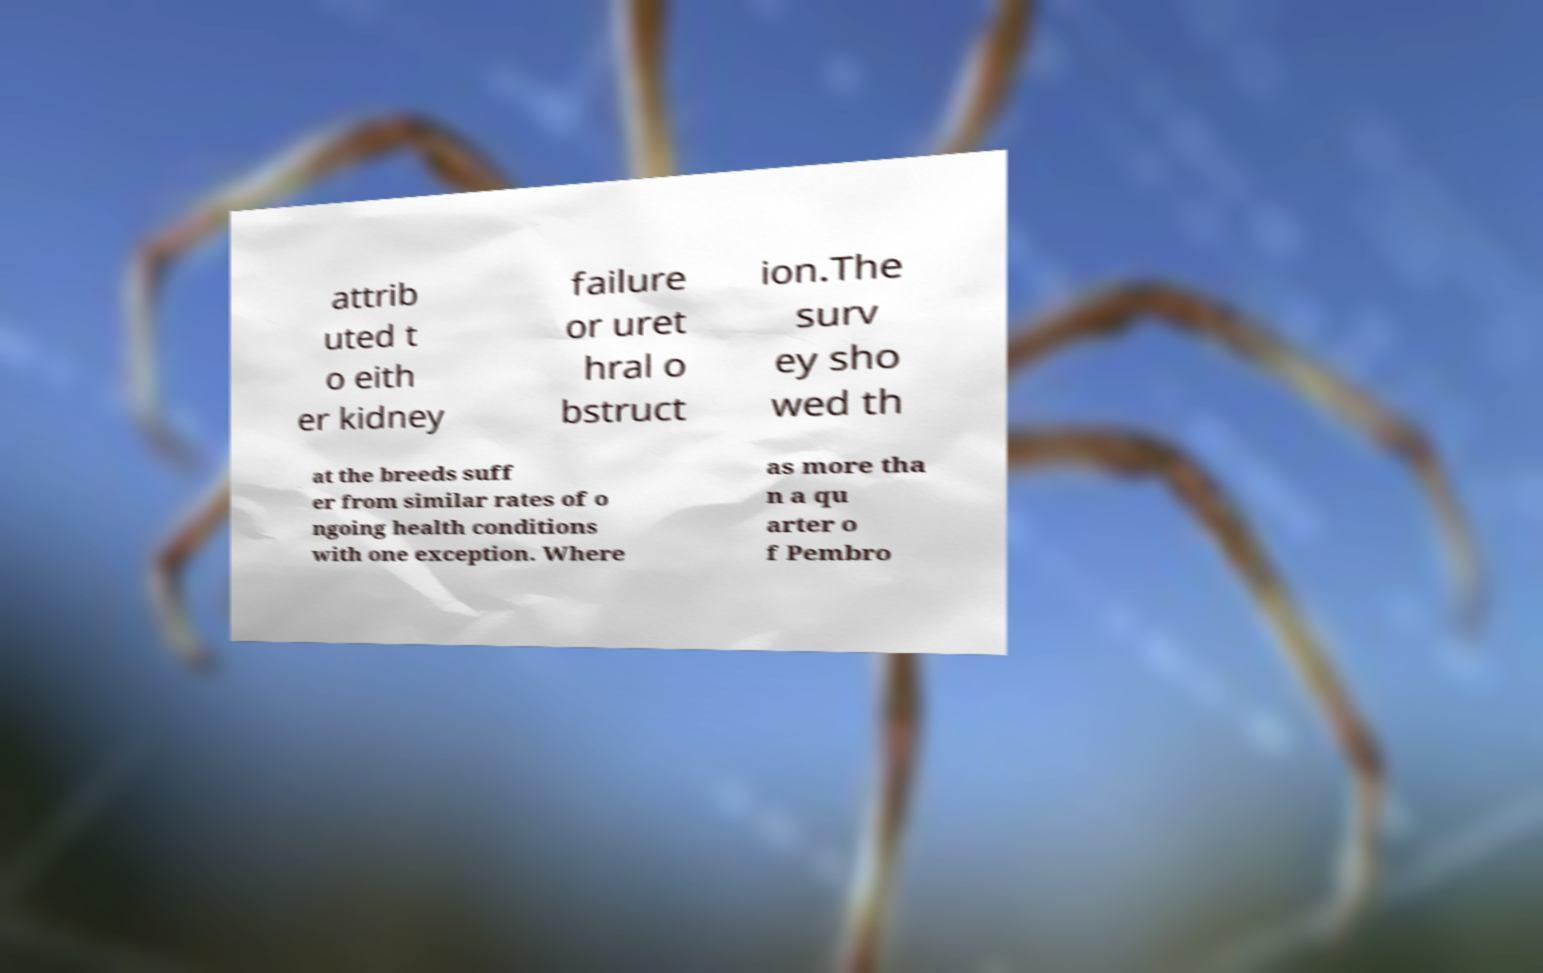Could you assist in decoding the text presented in this image and type it out clearly? attrib uted t o eith er kidney failure or uret hral o bstruct ion.The surv ey sho wed th at the breeds suff er from similar rates of o ngoing health conditions with one exception. Where as more tha n a qu arter o f Pembro 